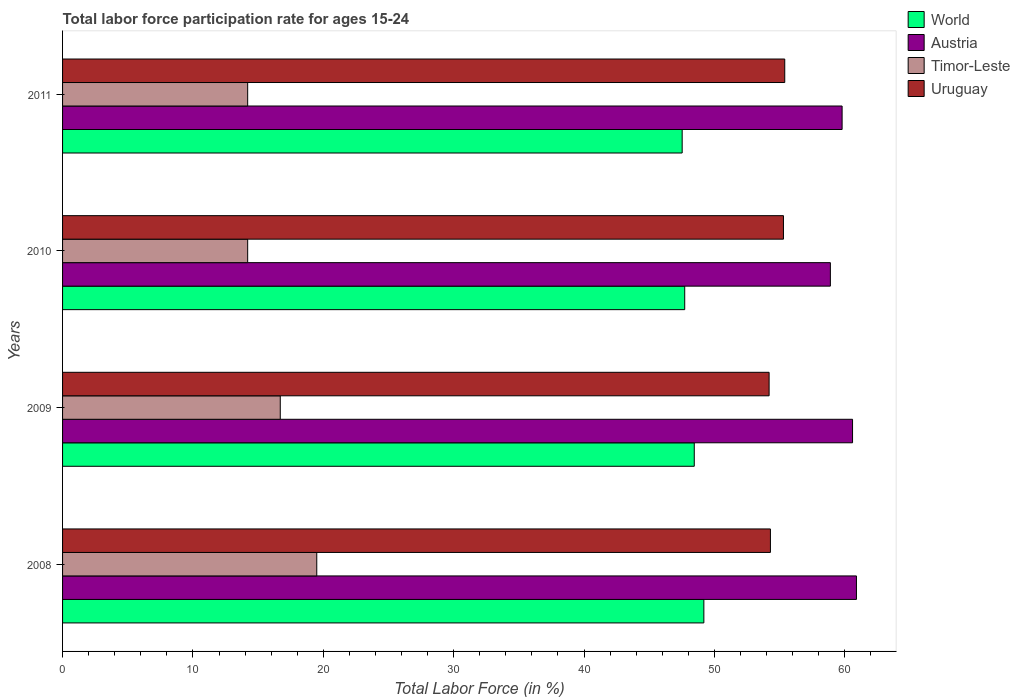How many groups of bars are there?
Provide a short and direct response. 4. Are the number of bars per tick equal to the number of legend labels?
Your answer should be very brief. Yes. Are the number of bars on each tick of the Y-axis equal?
Make the answer very short. Yes. How many bars are there on the 2nd tick from the top?
Offer a very short reply. 4. What is the label of the 2nd group of bars from the top?
Your response must be concise. 2010. In how many cases, is the number of bars for a given year not equal to the number of legend labels?
Make the answer very short. 0. What is the labor force participation rate in Austria in 2010?
Provide a short and direct response. 58.9. Across all years, what is the maximum labor force participation rate in Austria?
Offer a very short reply. 60.9. Across all years, what is the minimum labor force participation rate in Timor-Leste?
Provide a succinct answer. 14.2. In which year was the labor force participation rate in Timor-Leste maximum?
Ensure brevity in your answer.  2008. In which year was the labor force participation rate in Uruguay minimum?
Make the answer very short. 2009. What is the total labor force participation rate in World in the graph?
Provide a succinct answer. 192.91. What is the difference between the labor force participation rate in Timor-Leste in 2009 and that in 2010?
Offer a very short reply. 2.5. What is the difference between the labor force participation rate in Timor-Leste in 2009 and the labor force participation rate in Austria in 2011?
Keep it short and to the point. -43.1. What is the average labor force participation rate in World per year?
Your response must be concise. 48.23. In the year 2011, what is the difference between the labor force participation rate in World and labor force participation rate in Timor-Leste?
Your response must be concise. 33.33. In how many years, is the labor force participation rate in Uruguay greater than 52 %?
Offer a terse response. 4. What is the ratio of the labor force participation rate in Timor-Leste in 2009 to that in 2010?
Your answer should be compact. 1.18. Is the labor force participation rate in Austria in 2009 less than that in 2011?
Your answer should be compact. No. Is the difference between the labor force participation rate in World in 2008 and 2010 greater than the difference between the labor force participation rate in Timor-Leste in 2008 and 2010?
Give a very brief answer. No. What is the difference between the highest and the second highest labor force participation rate in Uruguay?
Provide a succinct answer. 0.1. What is the difference between the highest and the lowest labor force participation rate in Uruguay?
Your answer should be compact. 1.2. In how many years, is the labor force participation rate in World greater than the average labor force participation rate in World taken over all years?
Ensure brevity in your answer.  2. Is the sum of the labor force participation rate in Timor-Leste in 2009 and 2011 greater than the maximum labor force participation rate in Uruguay across all years?
Ensure brevity in your answer.  No. How many bars are there?
Make the answer very short. 16. Are all the bars in the graph horizontal?
Your response must be concise. Yes. How many years are there in the graph?
Keep it short and to the point. 4. What is the difference between two consecutive major ticks on the X-axis?
Provide a succinct answer. 10. Are the values on the major ticks of X-axis written in scientific E-notation?
Offer a terse response. No. Where does the legend appear in the graph?
Give a very brief answer. Top right. How many legend labels are there?
Offer a terse response. 4. How are the legend labels stacked?
Provide a succinct answer. Vertical. What is the title of the graph?
Offer a very short reply. Total labor force participation rate for ages 15-24. What is the Total Labor Force (in %) of World in 2008?
Provide a succinct answer. 49.19. What is the Total Labor Force (in %) of Austria in 2008?
Make the answer very short. 60.9. What is the Total Labor Force (in %) in Timor-Leste in 2008?
Ensure brevity in your answer.  19.5. What is the Total Labor Force (in %) in Uruguay in 2008?
Provide a succinct answer. 54.3. What is the Total Labor Force (in %) in World in 2009?
Make the answer very short. 48.46. What is the Total Labor Force (in %) of Austria in 2009?
Give a very brief answer. 60.6. What is the Total Labor Force (in %) in Timor-Leste in 2009?
Offer a terse response. 16.7. What is the Total Labor Force (in %) of Uruguay in 2009?
Your answer should be compact. 54.2. What is the Total Labor Force (in %) in World in 2010?
Make the answer very short. 47.73. What is the Total Labor Force (in %) of Austria in 2010?
Give a very brief answer. 58.9. What is the Total Labor Force (in %) in Timor-Leste in 2010?
Offer a terse response. 14.2. What is the Total Labor Force (in %) of Uruguay in 2010?
Ensure brevity in your answer.  55.3. What is the Total Labor Force (in %) in World in 2011?
Offer a terse response. 47.53. What is the Total Labor Force (in %) of Austria in 2011?
Make the answer very short. 59.8. What is the Total Labor Force (in %) of Timor-Leste in 2011?
Your answer should be very brief. 14.2. What is the Total Labor Force (in %) in Uruguay in 2011?
Offer a terse response. 55.4. Across all years, what is the maximum Total Labor Force (in %) of World?
Ensure brevity in your answer.  49.19. Across all years, what is the maximum Total Labor Force (in %) in Austria?
Provide a short and direct response. 60.9. Across all years, what is the maximum Total Labor Force (in %) of Timor-Leste?
Ensure brevity in your answer.  19.5. Across all years, what is the maximum Total Labor Force (in %) in Uruguay?
Provide a succinct answer. 55.4. Across all years, what is the minimum Total Labor Force (in %) of World?
Offer a terse response. 47.53. Across all years, what is the minimum Total Labor Force (in %) of Austria?
Provide a short and direct response. 58.9. Across all years, what is the minimum Total Labor Force (in %) of Timor-Leste?
Keep it short and to the point. 14.2. Across all years, what is the minimum Total Labor Force (in %) in Uruguay?
Offer a terse response. 54.2. What is the total Total Labor Force (in %) of World in the graph?
Your answer should be compact. 192.91. What is the total Total Labor Force (in %) of Austria in the graph?
Offer a terse response. 240.2. What is the total Total Labor Force (in %) in Timor-Leste in the graph?
Make the answer very short. 64.6. What is the total Total Labor Force (in %) in Uruguay in the graph?
Provide a succinct answer. 219.2. What is the difference between the Total Labor Force (in %) in World in 2008 and that in 2009?
Make the answer very short. 0.74. What is the difference between the Total Labor Force (in %) of Timor-Leste in 2008 and that in 2009?
Offer a very short reply. 2.8. What is the difference between the Total Labor Force (in %) in Uruguay in 2008 and that in 2009?
Provide a short and direct response. 0.1. What is the difference between the Total Labor Force (in %) in World in 2008 and that in 2010?
Offer a terse response. 1.47. What is the difference between the Total Labor Force (in %) in Uruguay in 2008 and that in 2010?
Give a very brief answer. -1. What is the difference between the Total Labor Force (in %) in World in 2008 and that in 2011?
Your answer should be very brief. 1.66. What is the difference between the Total Labor Force (in %) of Timor-Leste in 2008 and that in 2011?
Offer a terse response. 5.3. What is the difference between the Total Labor Force (in %) of Uruguay in 2008 and that in 2011?
Keep it short and to the point. -1.1. What is the difference between the Total Labor Force (in %) of World in 2009 and that in 2010?
Provide a succinct answer. 0.73. What is the difference between the Total Labor Force (in %) in Uruguay in 2009 and that in 2010?
Give a very brief answer. -1.1. What is the difference between the Total Labor Force (in %) of World in 2009 and that in 2011?
Your response must be concise. 0.93. What is the difference between the Total Labor Force (in %) of Timor-Leste in 2009 and that in 2011?
Ensure brevity in your answer.  2.5. What is the difference between the Total Labor Force (in %) in World in 2010 and that in 2011?
Offer a terse response. 0.2. What is the difference between the Total Labor Force (in %) of Austria in 2010 and that in 2011?
Your response must be concise. -0.9. What is the difference between the Total Labor Force (in %) in World in 2008 and the Total Labor Force (in %) in Austria in 2009?
Give a very brief answer. -11.41. What is the difference between the Total Labor Force (in %) in World in 2008 and the Total Labor Force (in %) in Timor-Leste in 2009?
Keep it short and to the point. 32.49. What is the difference between the Total Labor Force (in %) in World in 2008 and the Total Labor Force (in %) in Uruguay in 2009?
Offer a terse response. -5.01. What is the difference between the Total Labor Force (in %) of Austria in 2008 and the Total Labor Force (in %) of Timor-Leste in 2009?
Give a very brief answer. 44.2. What is the difference between the Total Labor Force (in %) in Timor-Leste in 2008 and the Total Labor Force (in %) in Uruguay in 2009?
Your answer should be very brief. -34.7. What is the difference between the Total Labor Force (in %) in World in 2008 and the Total Labor Force (in %) in Austria in 2010?
Your response must be concise. -9.71. What is the difference between the Total Labor Force (in %) of World in 2008 and the Total Labor Force (in %) of Timor-Leste in 2010?
Provide a succinct answer. 34.99. What is the difference between the Total Labor Force (in %) of World in 2008 and the Total Labor Force (in %) of Uruguay in 2010?
Keep it short and to the point. -6.11. What is the difference between the Total Labor Force (in %) of Austria in 2008 and the Total Labor Force (in %) of Timor-Leste in 2010?
Your answer should be compact. 46.7. What is the difference between the Total Labor Force (in %) of Timor-Leste in 2008 and the Total Labor Force (in %) of Uruguay in 2010?
Give a very brief answer. -35.8. What is the difference between the Total Labor Force (in %) of World in 2008 and the Total Labor Force (in %) of Austria in 2011?
Make the answer very short. -10.61. What is the difference between the Total Labor Force (in %) of World in 2008 and the Total Labor Force (in %) of Timor-Leste in 2011?
Provide a short and direct response. 34.99. What is the difference between the Total Labor Force (in %) in World in 2008 and the Total Labor Force (in %) in Uruguay in 2011?
Your answer should be compact. -6.21. What is the difference between the Total Labor Force (in %) of Austria in 2008 and the Total Labor Force (in %) of Timor-Leste in 2011?
Make the answer very short. 46.7. What is the difference between the Total Labor Force (in %) of Timor-Leste in 2008 and the Total Labor Force (in %) of Uruguay in 2011?
Offer a terse response. -35.9. What is the difference between the Total Labor Force (in %) of World in 2009 and the Total Labor Force (in %) of Austria in 2010?
Ensure brevity in your answer.  -10.44. What is the difference between the Total Labor Force (in %) of World in 2009 and the Total Labor Force (in %) of Timor-Leste in 2010?
Your answer should be compact. 34.26. What is the difference between the Total Labor Force (in %) in World in 2009 and the Total Labor Force (in %) in Uruguay in 2010?
Your response must be concise. -6.84. What is the difference between the Total Labor Force (in %) of Austria in 2009 and the Total Labor Force (in %) of Timor-Leste in 2010?
Your response must be concise. 46.4. What is the difference between the Total Labor Force (in %) in Timor-Leste in 2009 and the Total Labor Force (in %) in Uruguay in 2010?
Keep it short and to the point. -38.6. What is the difference between the Total Labor Force (in %) in World in 2009 and the Total Labor Force (in %) in Austria in 2011?
Provide a short and direct response. -11.34. What is the difference between the Total Labor Force (in %) of World in 2009 and the Total Labor Force (in %) of Timor-Leste in 2011?
Provide a short and direct response. 34.26. What is the difference between the Total Labor Force (in %) of World in 2009 and the Total Labor Force (in %) of Uruguay in 2011?
Keep it short and to the point. -6.94. What is the difference between the Total Labor Force (in %) in Austria in 2009 and the Total Labor Force (in %) in Timor-Leste in 2011?
Your answer should be compact. 46.4. What is the difference between the Total Labor Force (in %) of Timor-Leste in 2009 and the Total Labor Force (in %) of Uruguay in 2011?
Your response must be concise. -38.7. What is the difference between the Total Labor Force (in %) in World in 2010 and the Total Labor Force (in %) in Austria in 2011?
Your answer should be compact. -12.07. What is the difference between the Total Labor Force (in %) of World in 2010 and the Total Labor Force (in %) of Timor-Leste in 2011?
Your answer should be compact. 33.53. What is the difference between the Total Labor Force (in %) in World in 2010 and the Total Labor Force (in %) in Uruguay in 2011?
Provide a short and direct response. -7.67. What is the difference between the Total Labor Force (in %) in Austria in 2010 and the Total Labor Force (in %) in Timor-Leste in 2011?
Your answer should be very brief. 44.7. What is the difference between the Total Labor Force (in %) of Austria in 2010 and the Total Labor Force (in %) of Uruguay in 2011?
Provide a short and direct response. 3.5. What is the difference between the Total Labor Force (in %) of Timor-Leste in 2010 and the Total Labor Force (in %) of Uruguay in 2011?
Offer a terse response. -41.2. What is the average Total Labor Force (in %) of World per year?
Ensure brevity in your answer.  48.23. What is the average Total Labor Force (in %) of Austria per year?
Offer a very short reply. 60.05. What is the average Total Labor Force (in %) in Timor-Leste per year?
Offer a terse response. 16.15. What is the average Total Labor Force (in %) of Uruguay per year?
Give a very brief answer. 54.8. In the year 2008, what is the difference between the Total Labor Force (in %) of World and Total Labor Force (in %) of Austria?
Provide a succinct answer. -11.71. In the year 2008, what is the difference between the Total Labor Force (in %) in World and Total Labor Force (in %) in Timor-Leste?
Ensure brevity in your answer.  29.69. In the year 2008, what is the difference between the Total Labor Force (in %) in World and Total Labor Force (in %) in Uruguay?
Offer a terse response. -5.11. In the year 2008, what is the difference between the Total Labor Force (in %) of Austria and Total Labor Force (in %) of Timor-Leste?
Give a very brief answer. 41.4. In the year 2008, what is the difference between the Total Labor Force (in %) of Austria and Total Labor Force (in %) of Uruguay?
Provide a succinct answer. 6.6. In the year 2008, what is the difference between the Total Labor Force (in %) of Timor-Leste and Total Labor Force (in %) of Uruguay?
Make the answer very short. -34.8. In the year 2009, what is the difference between the Total Labor Force (in %) in World and Total Labor Force (in %) in Austria?
Give a very brief answer. -12.14. In the year 2009, what is the difference between the Total Labor Force (in %) of World and Total Labor Force (in %) of Timor-Leste?
Provide a short and direct response. 31.76. In the year 2009, what is the difference between the Total Labor Force (in %) of World and Total Labor Force (in %) of Uruguay?
Provide a succinct answer. -5.74. In the year 2009, what is the difference between the Total Labor Force (in %) of Austria and Total Labor Force (in %) of Timor-Leste?
Your answer should be very brief. 43.9. In the year 2009, what is the difference between the Total Labor Force (in %) of Timor-Leste and Total Labor Force (in %) of Uruguay?
Offer a very short reply. -37.5. In the year 2010, what is the difference between the Total Labor Force (in %) of World and Total Labor Force (in %) of Austria?
Your response must be concise. -11.17. In the year 2010, what is the difference between the Total Labor Force (in %) in World and Total Labor Force (in %) in Timor-Leste?
Give a very brief answer. 33.53. In the year 2010, what is the difference between the Total Labor Force (in %) of World and Total Labor Force (in %) of Uruguay?
Give a very brief answer. -7.57. In the year 2010, what is the difference between the Total Labor Force (in %) of Austria and Total Labor Force (in %) of Timor-Leste?
Your answer should be compact. 44.7. In the year 2010, what is the difference between the Total Labor Force (in %) of Austria and Total Labor Force (in %) of Uruguay?
Offer a terse response. 3.6. In the year 2010, what is the difference between the Total Labor Force (in %) in Timor-Leste and Total Labor Force (in %) in Uruguay?
Your answer should be compact. -41.1. In the year 2011, what is the difference between the Total Labor Force (in %) in World and Total Labor Force (in %) in Austria?
Provide a short and direct response. -12.27. In the year 2011, what is the difference between the Total Labor Force (in %) in World and Total Labor Force (in %) in Timor-Leste?
Ensure brevity in your answer.  33.33. In the year 2011, what is the difference between the Total Labor Force (in %) of World and Total Labor Force (in %) of Uruguay?
Your answer should be compact. -7.87. In the year 2011, what is the difference between the Total Labor Force (in %) of Austria and Total Labor Force (in %) of Timor-Leste?
Make the answer very short. 45.6. In the year 2011, what is the difference between the Total Labor Force (in %) of Timor-Leste and Total Labor Force (in %) of Uruguay?
Your answer should be compact. -41.2. What is the ratio of the Total Labor Force (in %) in World in 2008 to that in 2009?
Give a very brief answer. 1.02. What is the ratio of the Total Labor Force (in %) of Austria in 2008 to that in 2009?
Ensure brevity in your answer.  1. What is the ratio of the Total Labor Force (in %) of Timor-Leste in 2008 to that in 2009?
Your response must be concise. 1.17. What is the ratio of the Total Labor Force (in %) in Uruguay in 2008 to that in 2009?
Keep it short and to the point. 1. What is the ratio of the Total Labor Force (in %) of World in 2008 to that in 2010?
Make the answer very short. 1.03. What is the ratio of the Total Labor Force (in %) in Austria in 2008 to that in 2010?
Offer a terse response. 1.03. What is the ratio of the Total Labor Force (in %) of Timor-Leste in 2008 to that in 2010?
Make the answer very short. 1.37. What is the ratio of the Total Labor Force (in %) of Uruguay in 2008 to that in 2010?
Offer a very short reply. 0.98. What is the ratio of the Total Labor Force (in %) of World in 2008 to that in 2011?
Your answer should be compact. 1.03. What is the ratio of the Total Labor Force (in %) in Austria in 2008 to that in 2011?
Give a very brief answer. 1.02. What is the ratio of the Total Labor Force (in %) in Timor-Leste in 2008 to that in 2011?
Offer a terse response. 1.37. What is the ratio of the Total Labor Force (in %) of Uruguay in 2008 to that in 2011?
Provide a short and direct response. 0.98. What is the ratio of the Total Labor Force (in %) of World in 2009 to that in 2010?
Your answer should be compact. 1.02. What is the ratio of the Total Labor Force (in %) in Austria in 2009 to that in 2010?
Keep it short and to the point. 1.03. What is the ratio of the Total Labor Force (in %) of Timor-Leste in 2009 to that in 2010?
Offer a terse response. 1.18. What is the ratio of the Total Labor Force (in %) in Uruguay in 2009 to that in 2010?
Offer a terse response. 0.98. What is the ratio of the Total Labor Force (in %) of World in 2009 to that in 2011?
Your response must be concise. 1.02. What is the ratio of the Total Labor Force (in %) of Austria in 2009 to that in 2011?
Make the answer very short. 1.01. What is the ratio of the Total Labor Force (in %) of Timor-Leste in 2009 to that in 2011?
Ensure brevity in your answer.  1.18. What is the ratio of the Total Labor Force (in %) of Uruguay in 2009 to that in 2011?
Provide a short and direct response. 0.98. What is the ratio of the Total Labor Force (in %) of World in 2010 to that in 2011?
Make the answer very short. 1. What is the ratio of the Total Labor Force (in %) of Austria in 2010 to that in 2011?
Keep it short and to the point. 0.98. What is the ratio of the Total Labor Force (in %) in Timor-Leste in 2010 to that in 2011?
Give a very brief answer. 1. What is the difference between the highest and the second highest Total Labor Force (in %) in World?
Your answer should be compact. 0.74. What is the difference between the highest and the second highest Total Labor Force (in %) of Timor-Leste?
Provide a short and direct response. 2.8. What is the difference between the highest and the second highest Total Labor Force (in %) in Uruguay?
Provide a succinct answer. 0.1. What is the difference between the highest and the lowest Total Labor Force (in %) of World?
Your response must be concise. 1.66. What is the difference between the highest and the lowest Total Labor Force (in %) in Timor-Leste?
Offer a very short reply. 5.3. 